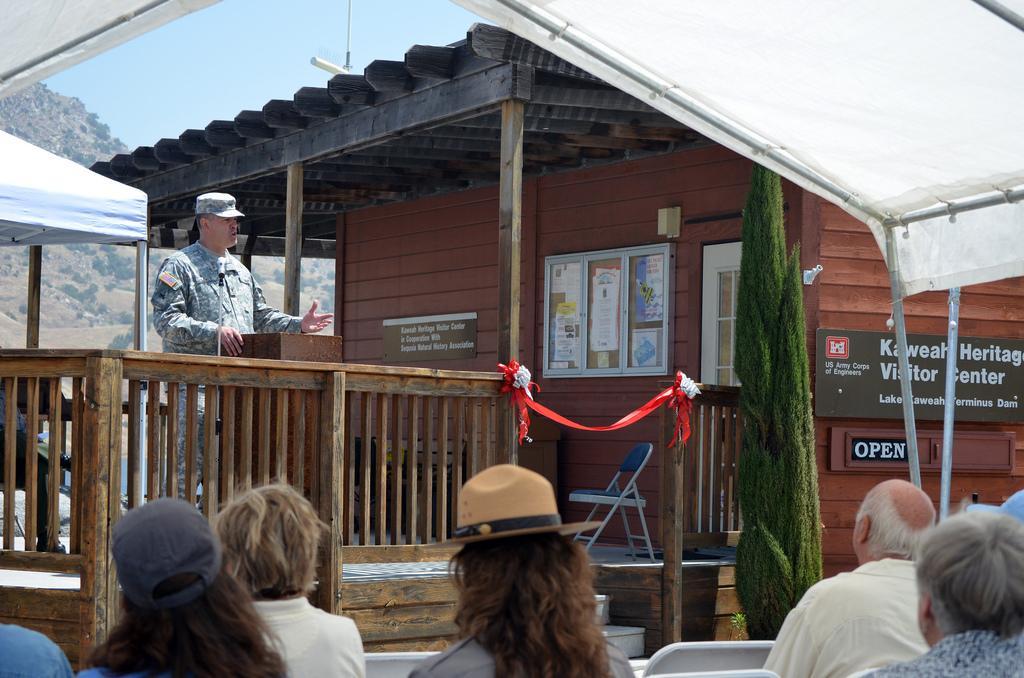Can you describe this image briefly? In this image I can see a house and in front of the house I can see a person standing in front of the table and i can see a chair and red color cloth visible in the middle ,at the bottom I can see few persons ,at the top I can see the sky and the hill 